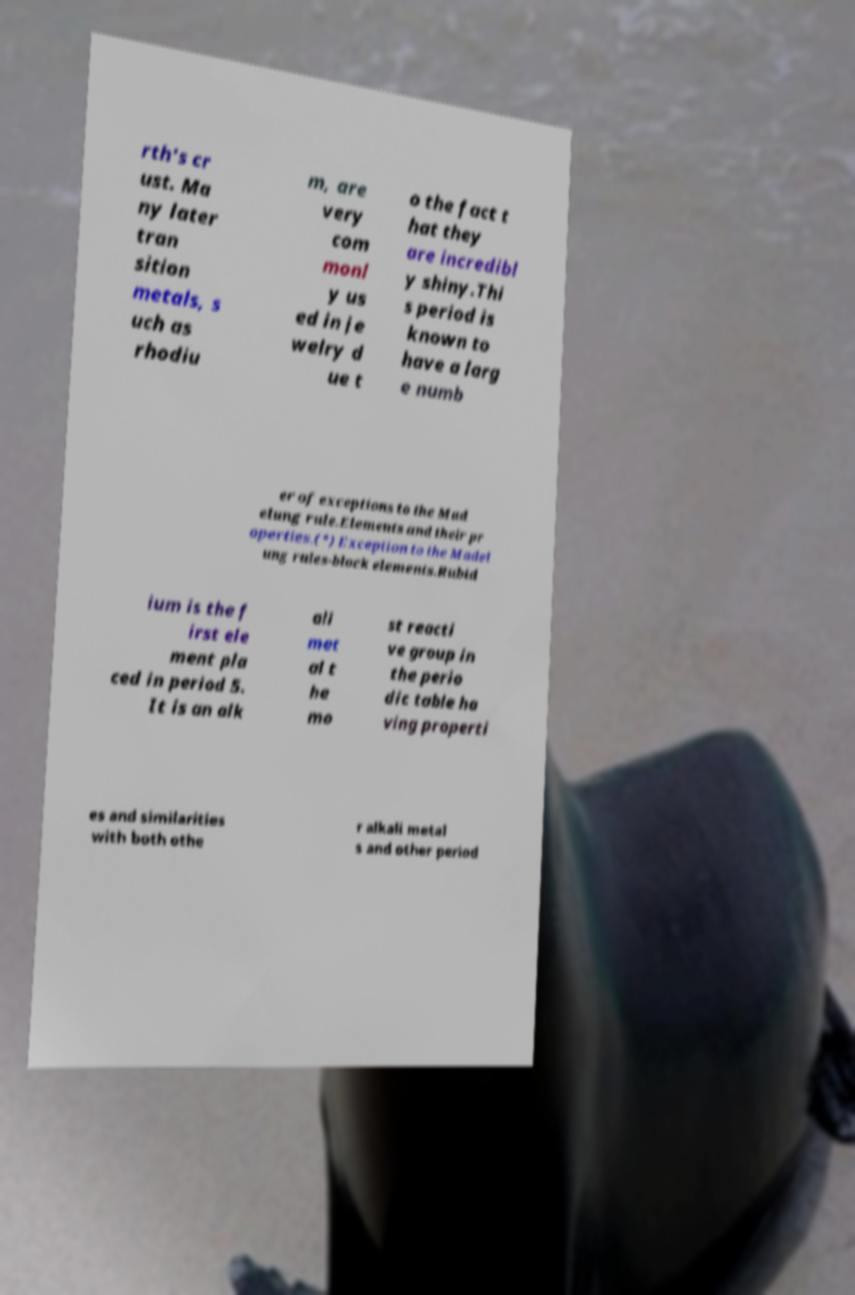There's text embedded in this image that I need extracted. Can you transcribe it verbatim? rth's cr ust. Ma ny later tran sition metals, s uch as rhodiu m, are very com monl y us ed in je welry d ue t o the fact t hat they are incredibl y shiny.Thi s period is known to have a larg e numb er of exceptions to the Mad elung rule.Elements and their pr operties.(*) Exception to the Madel ung rules-block elements.Rubid ium is the f irst ele ment pla ced in period 5. It is an alk ali met al t he mo st reacti ve group in the perio dic table ha ving properti es and similarities with both othe r alkali metal s and other period 